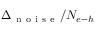Convert formula to latex. <formula><loc_0><loc_0><loc_500><loc_500>\Delta _ { n o i s e } / N _ { e { - } h }</formula> 